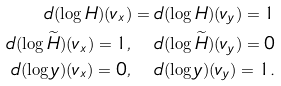Convert formula to latex. <formula><loc_0><loc_0><loc_500><loc_500>d ( \log H ) ( v _ { x } ) = d ( \log H ) ( v _ { y } ) = 1 \\ d ( \log \widetilde { H } ) ( v _ { x } ) = 1 , \quad d ( \log \widetilde { H } ) ( v _ { y } ) = 0 \\ d ( \log y ) ( v _ { x } ) = 0 , \quad d ( \log y ) ( v _ { y } ) = 1 .</formula> 